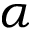Convert formula to latex. <formula><loc_0><loc_0><loc_500><loc_500>\alpha</formula> 